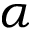Convert formula to latex. <formula><loc_0><loc_0><loc_500><loc_500>\alpha</formula> 